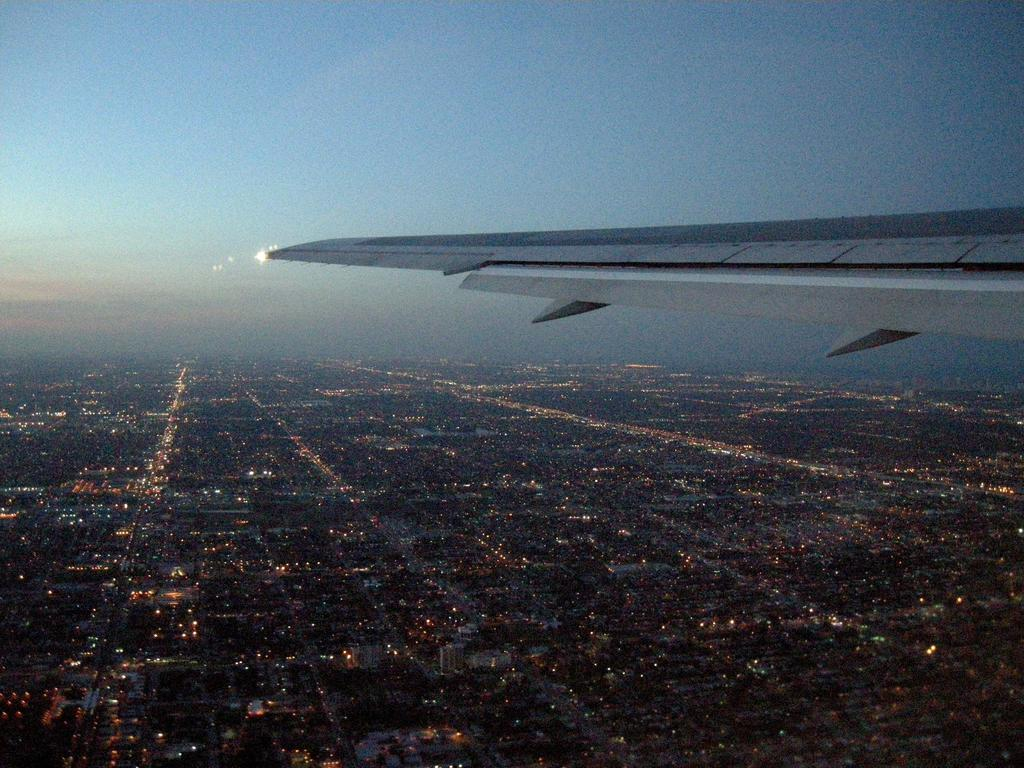What is the main subject in the center of the image? There is an airplane in the center of the image. What can be seen at the bottom of the image? There are buildings and lights at the bottom of the image. What is visible at the top of the image? The sky is visible at the top of the image. What type of tools does the carpenter use on the stage in the image? There is no carpenter or stage present in the image. What does the dad do in the image? There is no dad present in the image. 